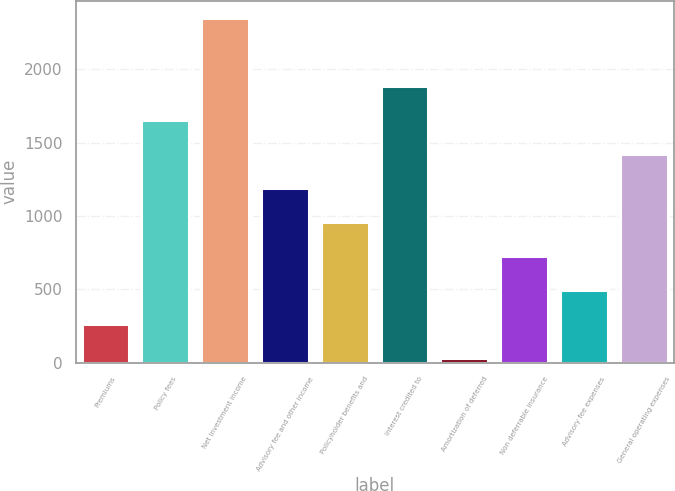<chart> <loc_0><loc_0><loc_500><loc_500><bar_chart><fcel>Premiums<fcel>Policy fees<fcel>Net investment income<fcel>Advisory fee and other income<fcel>Policyholder benefits and<fcel>Interest credited to<fcel>Amortization of deferred<fcel>Non deferrable insurance<fcel>Advisory fee expenses<fcel>General operating expenses<nl><fcel>262.8<fcel>1653.6<fcel>2349<fcel>1190<fcel>958.2<fcel>1885.4<fcel>31<fcel>726.4<fcel>494.6<fcel>1421.8<nl></chart> 